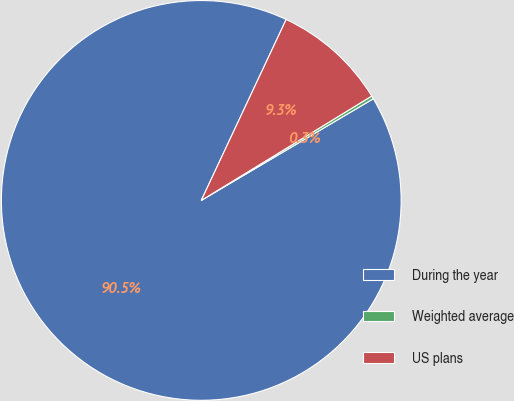Convert chart to OTSL. <chart><loc_0><loc_0><loc_500><loc_500><pie_chart><fcel>During the year<fcel>Weighted average<fcel>US plans<nl><fcel>90.47%<fcel>0.25%<fcel>9.27%<nl></chart> 